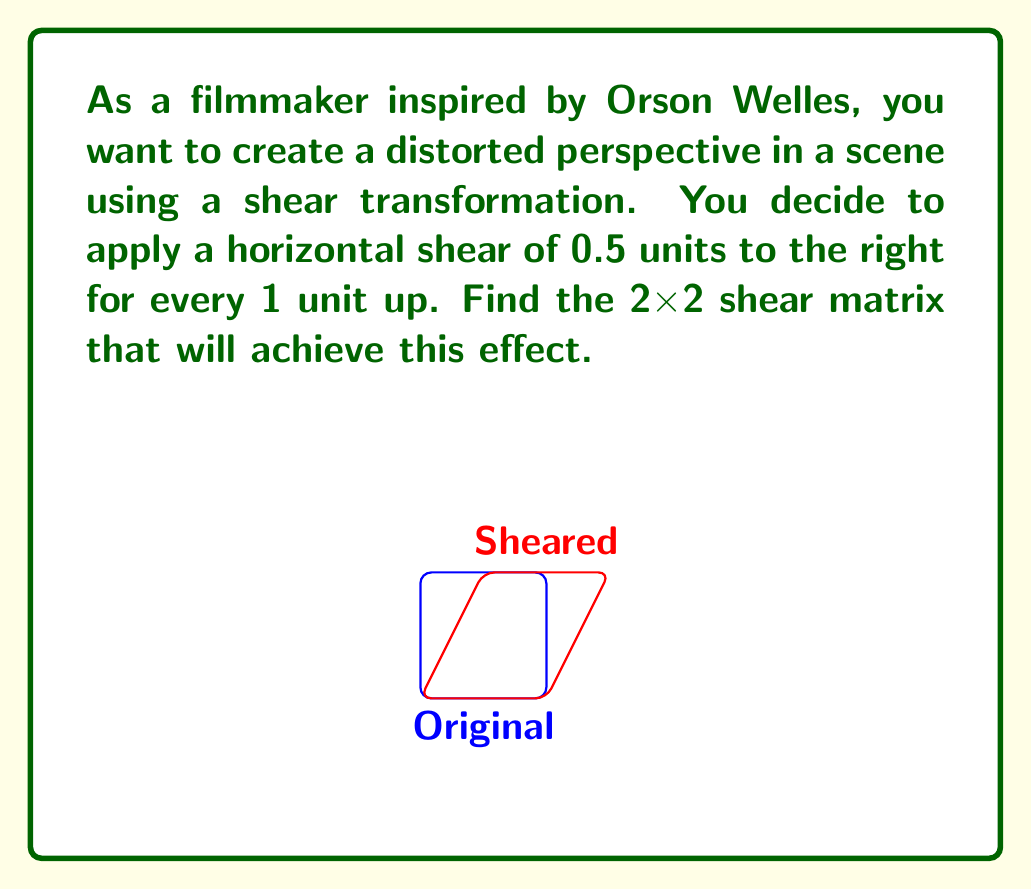Can you answer this question? To find the shear matrix, we'll follow these steps:

1) The general form of a horizontal shear matrix is:

   $$\begin{bmatrix} 1 & k \\ 0 & 1 \end{bmatrix}$$

   where $k$ is the shear factor.

2) In this case, we're shearing 0.5 units to the right for every 1 unit up. This means our shear factor $k = 0.5$.

3) Substituting this value into our general shear matrix:

   $$\begin{bmatrix} 1 & 0.5 \\ 0 & 1 \end{bmatrix}$$

4) To verify, let's see how this matrix transforms a point $(x, y)$:

   $$\begin{bmatrix} 1 & 0.5 \\ 0 & 1 \end{bmatrix} \begin{bmatrix} x \\ y \end{bmatrix} = \begin{bmatrix} x + 0.5y \\ y \end{bmatrix}$$

   This shows that the x-coordinate is shifted by $0.5y$, which is exactly the effect we want.

Thus, the 2x2 shear matrix that will create the desired distorted perspective is $\begin{bmatrix} 1 & 0.5 \\ 0 & 1 \end{bmatrix}$.
Answer: $$\begin{bmatrix} 1 & 0.5 \\ 0 & 1 \end{bmatrix}$$ 